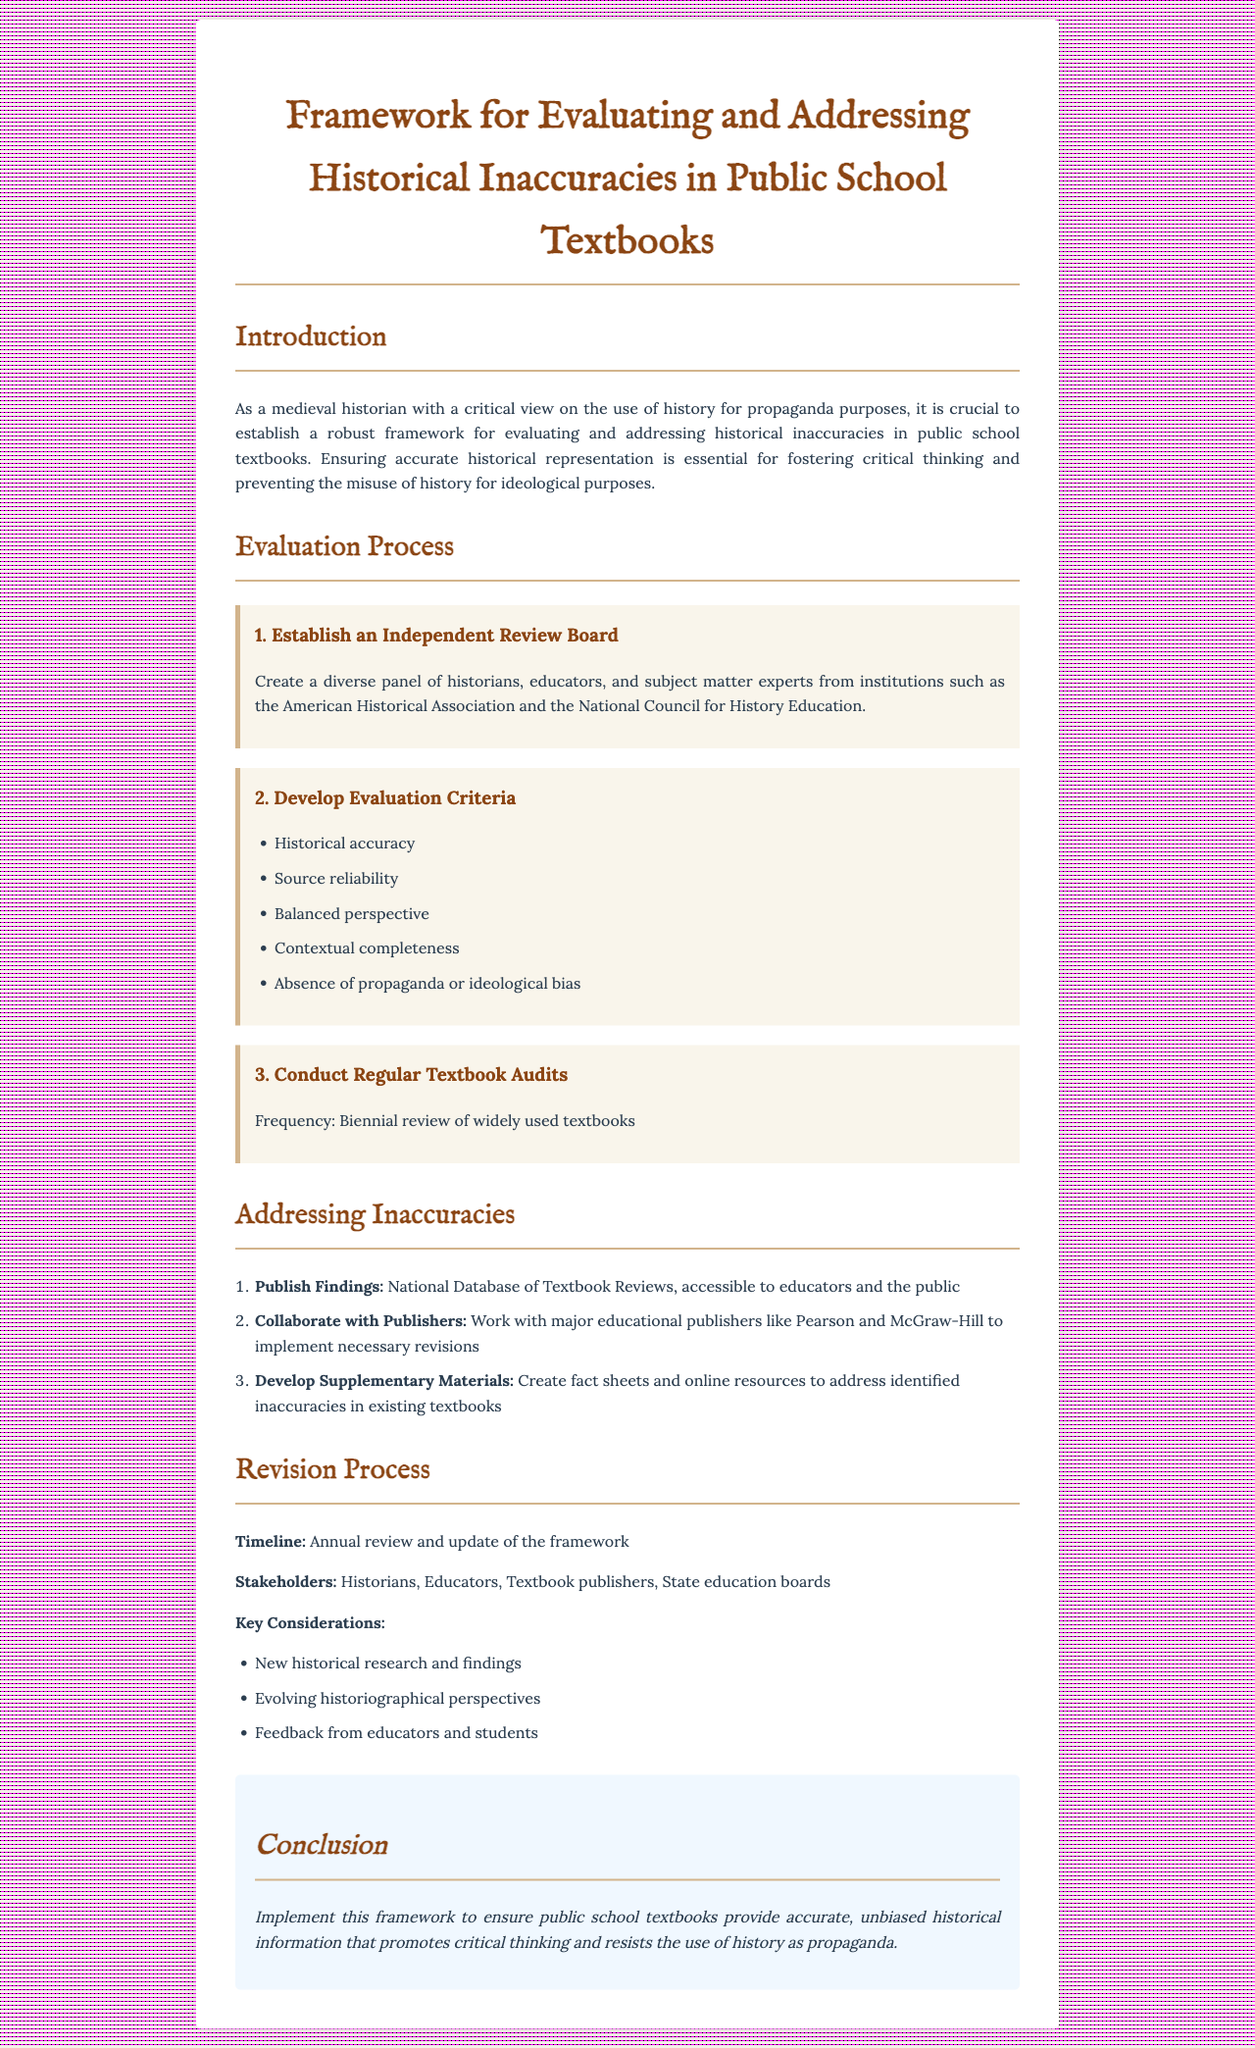What is the title of the document? The title of the document is stated at the top of the rendered content.
Answer: Framework for Evaluating and Addressing Historical Inaccuracies in Public School Textbooks What is the frequency of textbook audits? The frequency of the audits is specified in the evaluation process section.
Answer: Biennial Who is responsible for publishing findings? The document indicates a national database of textbook reviews will be established to publish findings.
Answer: National Database of Textbook Reviews What are the key stakeholders in the revision process? The stakeholders are listed in the revision process section of the document.
Answer: Historians, Educators, Textbook publishers, State education boards What is one of the criteria for evaluating textbooks? The criteria for evaluation include several aspects mentioned in the document.
Answer: Historical accuracy What is the purpose of the framework? The purpose is outlined in the introduction, describing the need for accurate historical representation.
Answer: Ensure accurate historical representation How often will the framework be reviewed and updated? The document specifies a timeline for review and update in the revision process section.
Answer: Annual Which organizations are suggested for forming the review board? The document suggests including specific professional organizations for forming the board.
Answer: American Historical Association and National Council for History Education What is the concluding statement's focus? The conclusion emphasizes the overall aim of the framework outlined in the document.
Answer: Accurate, unbiased historical information 